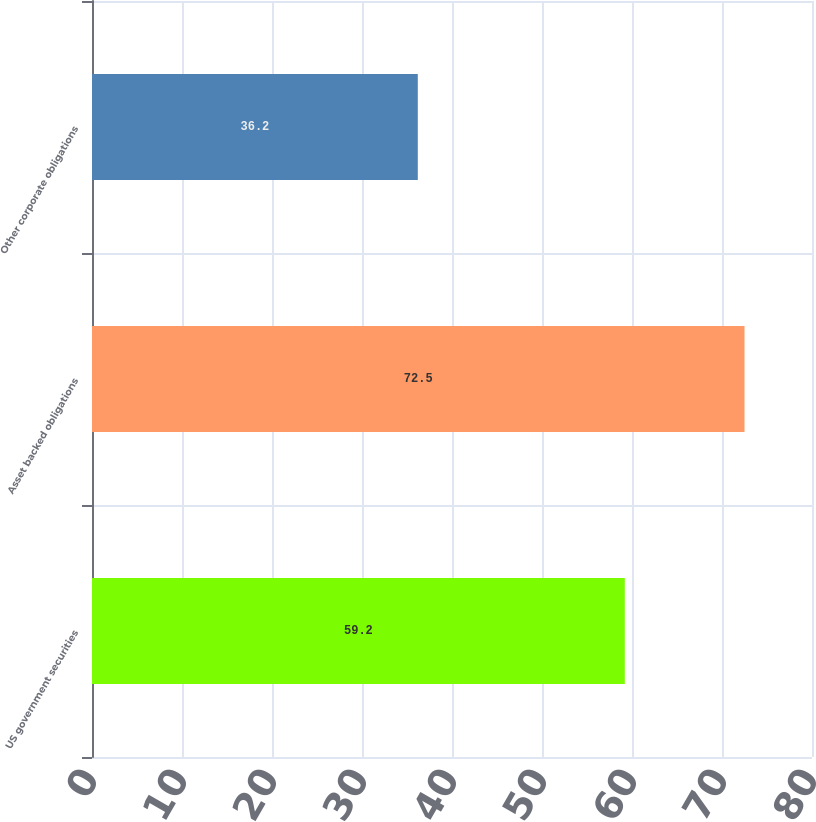Convert chart. <chart><loc_0><loc_0><loc_500><loc_500><bar_chart><fcel>US government securities<fcel>Asset backed obligations<fcel>Other corporate obligations<nl><fcel>59.2<fcel>72.5<fcel>36.2<nl></chart> 